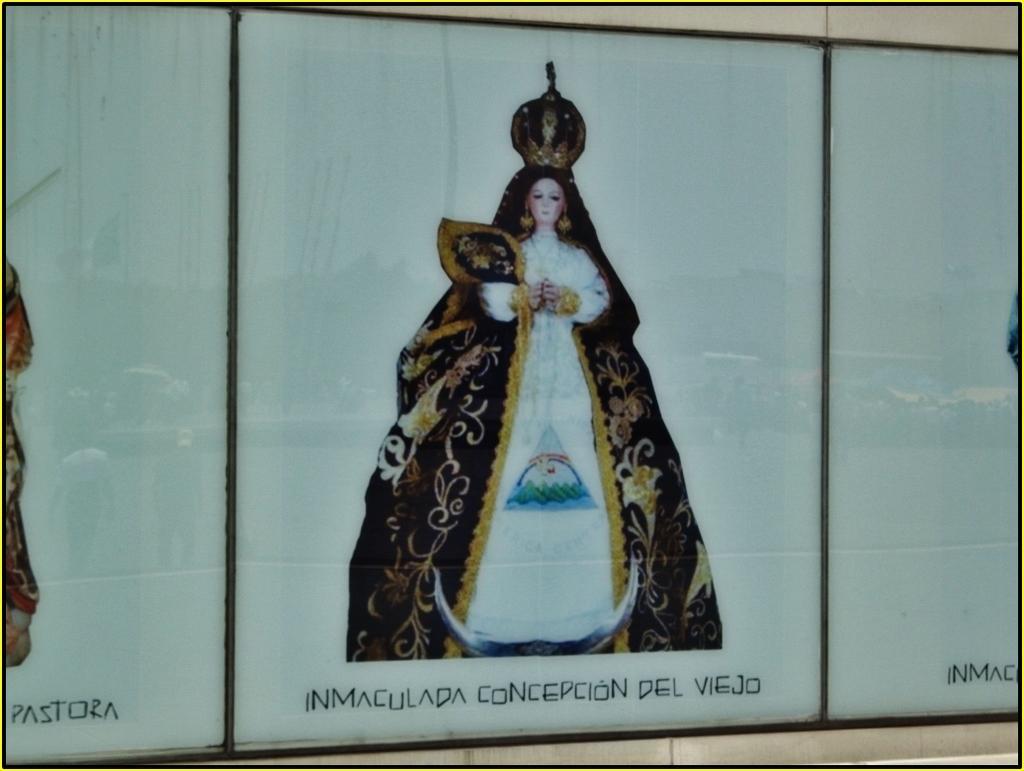How would you summarize this image in a sentence or two? In the center of the image there is a depiction of a lady. 